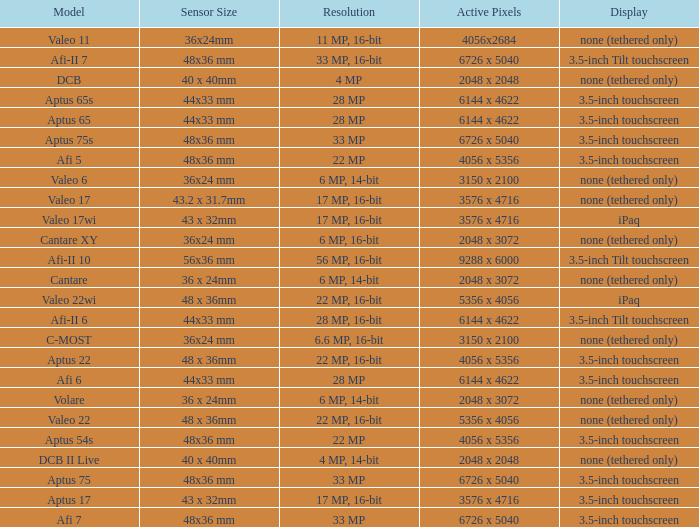Which model has a sensor sized 48x36 mm, pixels of 6726 x 5040, and a 33 mp resolution? Afi 7, Aptus 75s, Aptus 75. 